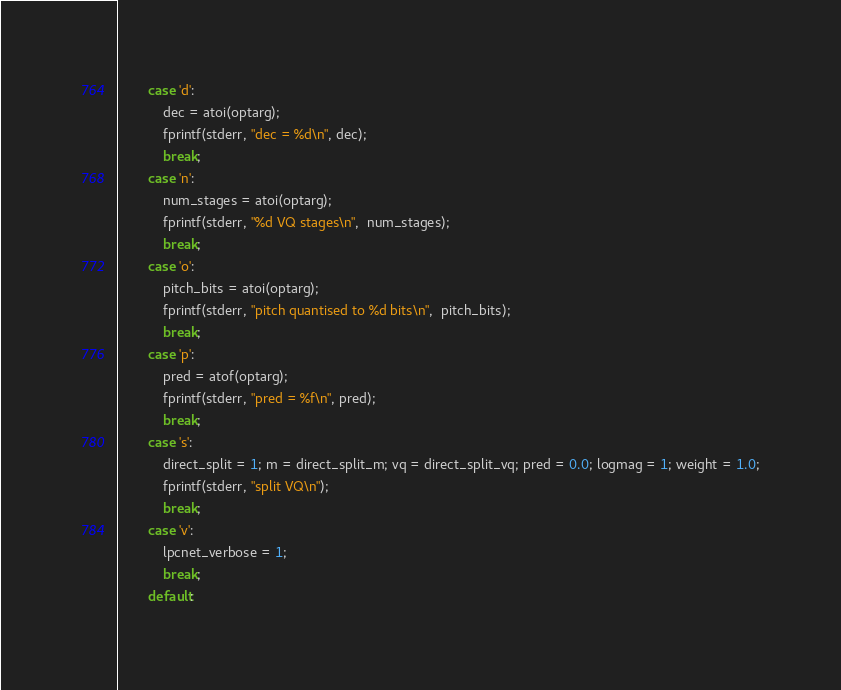Convert code to text. <code><loc_0><loc_0><loc_500><loc_500><_C_>        case 'd':
            dec = atoi(optarg);
            fprintf(stderr, "dec = %d\n", dec);
            break;
        case 'n':
            num_stages = atoi(optarg);
            fprintf(stderr, "%d VQ stages\n",  num_stages);
            break;
        case 'o':
            pitch_bits = atoi(optarg);
            fprintf(stderr, "pitch quantised to %d bits\n",  pitch_bits);
            break;
        case 'p':
            pred = atof(optarg);
            fprintf(stderr, "pred = %f\n", pred);
            break;
        case 's':
            direct_split = 1; m = direct_split_m; vq = direct_split_vq; pred = 0.0; logmag = 1; weight = 1.0;
            fprintf(stderr, "split VQ\n");
            break;
        case 'v':
            lpcnet_verbose = 1;
            break;
        default:</code> 